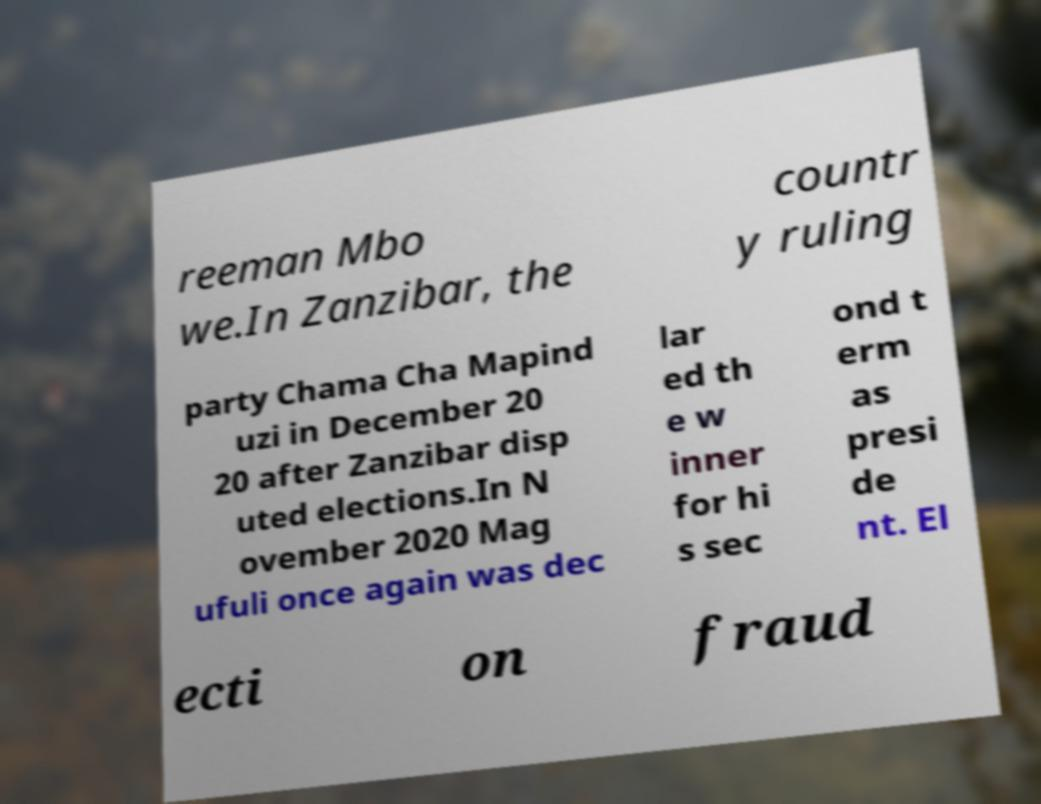Can you read and provide the text displayed in the image?This photo seems to have some interesting text. Can you extract and type it out for me? reeman Mbo we.In Zanzibar, the countr y ruling party Chama Cha Mapind uzi in December 20 20 after Zanzibar disp uted elections.In N ovember 2020 Mag ufuli once again was dec lar ed th e w inner for hi s sec ond t erm as presi de nt. El ecti on fraud 